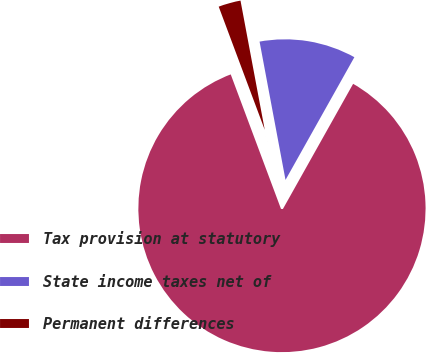<chart> <loc_0><loc_0><loc_500><loc_500><pie_chart><fcel>Tax provision at statutory<fcel>State income taxes net of<fcel>Permanent differences<nl><fcel>86.17%<fcel>11.09%<fcel>2.74%<nl></chart> 